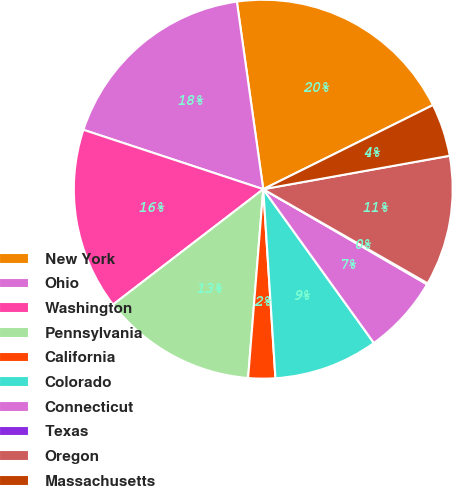<chart> <loc_0><loc_0><loc_500><loc_500><pie_chart><fcel>New York<fcel>Ohio<fcel>Washington<fcel>Pennsylvania<fcel>California<fcel>Colorado<fcel>Connecticut<fcel>Texas<fcel>Oregon<fcel>Massachusetts<nl><fcel>19.9%<fcel>17.7%<fcel>15.5%<fcel>13.3%<fcel>2.3%<fcel>8.9%<fcel>6.7%<fcel>0.1%<fcel>11.1%<fcel>4.5%<nl></chart> 